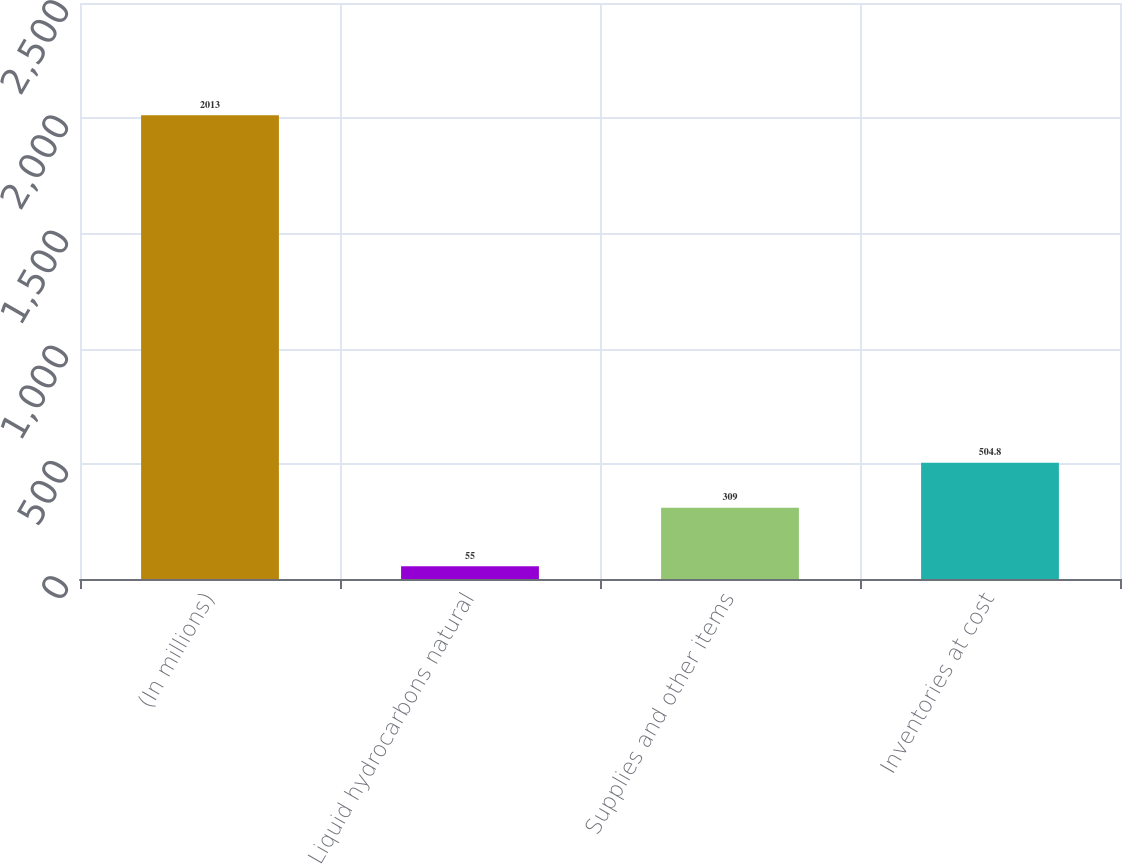<chart> <loc_0><loc_0><loc_500><loc_500><bar_chart><fcel>(In millions)<fcel>Liquid hydrocarbons natural<fcel>Supplies and other items<fcel>Inventories at cost<nl><fcel>2013<fcel>55<fcel>309<fcel>504.8<nl></chart> 